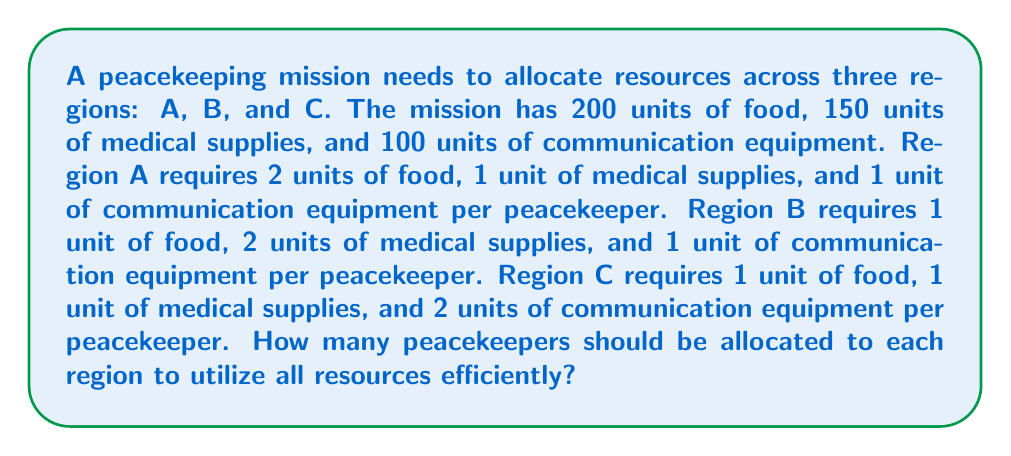Help me with this question. Let's approach this step-by-step using a system of linear equations:

1) Let $x$, $y$, and $z$ represent the number of peacekeepers in regions A, B, and C respectively.

2) We can set up three equations based on the resource constraints:

   Food: $2x + y + z = 200$
   Medical supplies: $x + 2y + z = 150$
   Communication equipment: $x + y + 2z = 100$

3) We now have a system of linear equations:

   $$\begin{cases}
   2x + y + z = 200 \\
   x + 2y + z = 150 \\
   x + y + 2z = 100
   \end{cases}$$

4) We can solve this using elimination method:
   Subtract equation 2 from equation 1:
   $x - y = 50$ ... (4)

5) Subtract equation 3 from equation 2:
   $y - z = 50$ ... (5)

6) From (4): $x = y + 50$
   From (5): $y = z + 50$

7) Substituting these into equation 3:
   $(z + 100) + (z + 50) + 2z = 100$
   $4z + 150 = 100$
   $4z = -50$
   $z = -12.5$

8) Since we can't have negative peacekeepers, this solution is not feasible in the real world. This means there's no way to use all resources completely efficiently.

9) For a practical solution, we need to round down to ensure we don't exceed any resource limits. Let's set $z = 0$, then from (5), $y = 50$, and from (4), $x = 100$.

10) Checking our resource usage:
    Food: $2(100) + 50 + 0 = 250$ (exceeds by 50)
    Medical supplies: $100 + 2(50) + 0 = 200$ (exceeds by 50)
    Communication equipment: $100 + 50 + 2(0) = 150$ (exceeds by 50)

11) To stay within limits, we need to reduce each by 1/4:
    $x = 75$, $y = 37$, $z = 0$

12) Final resource usage:
    Food: $2(75) + 37 + 0 = 187$
    Medical supplies: $75 + 2(37) + 0 = 149$
    Communication equipment: $75 + 37 + 2(0) = 112$

This solution uses resources most efficiently while staying within limits.
Answer: Region A: 75 peacekeepers, Region B: 37 peacekeepers, Region C: 0 peacekeepers 